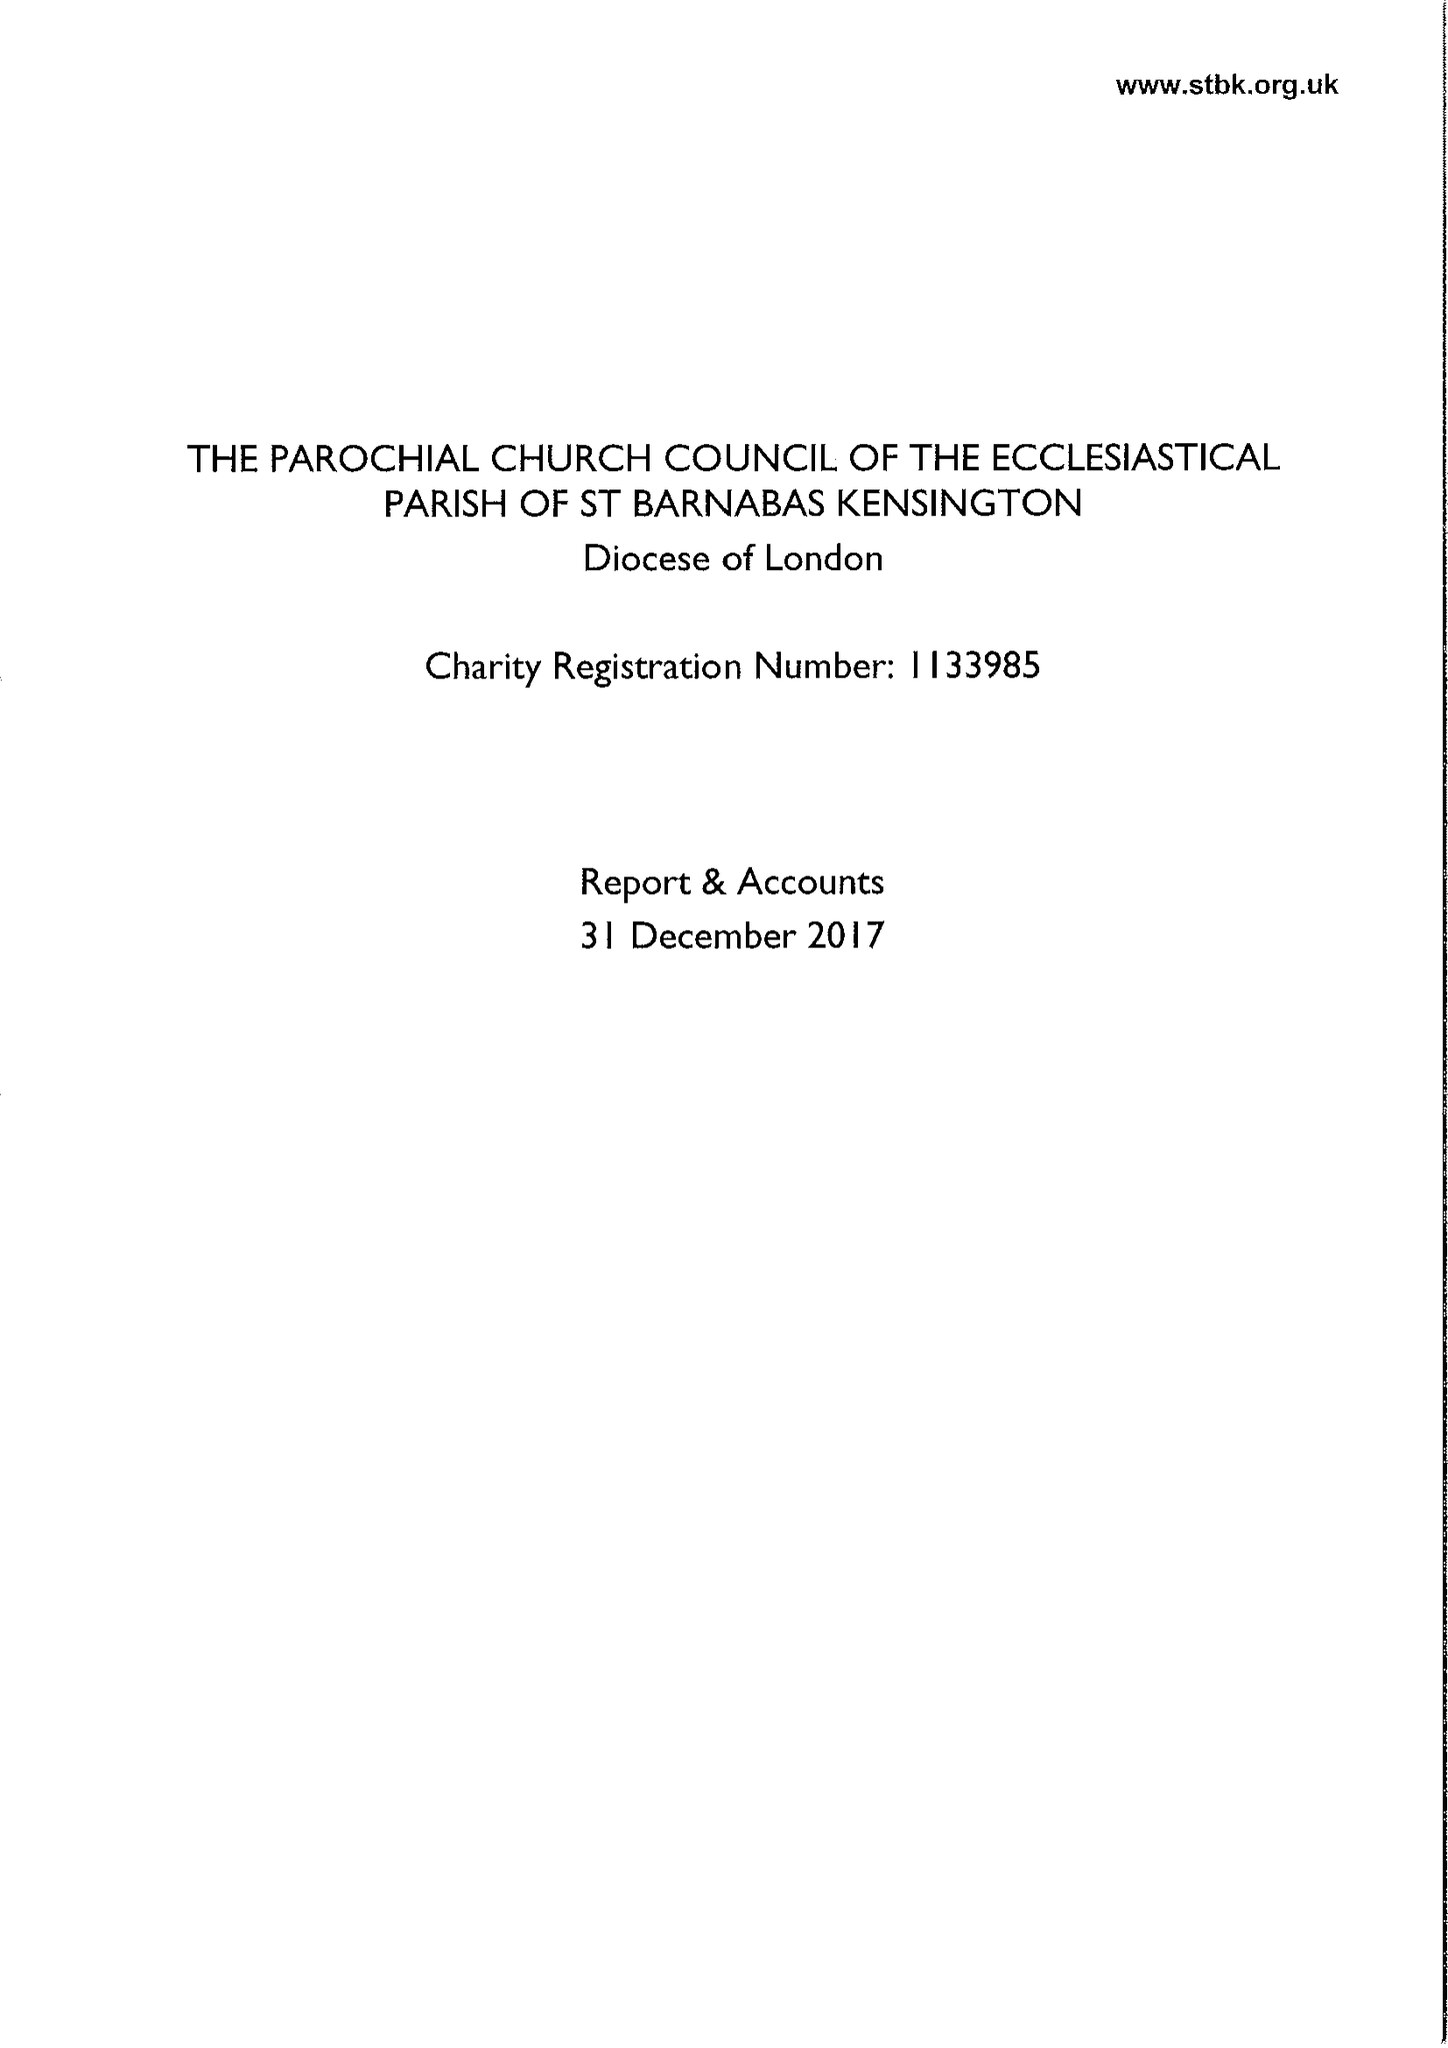What is the value for the charity_name?
Answer the question using a single word or phrase. The Parochial Church Council Of The Ecclesiastical Parish Of St Barnabas Kensington 